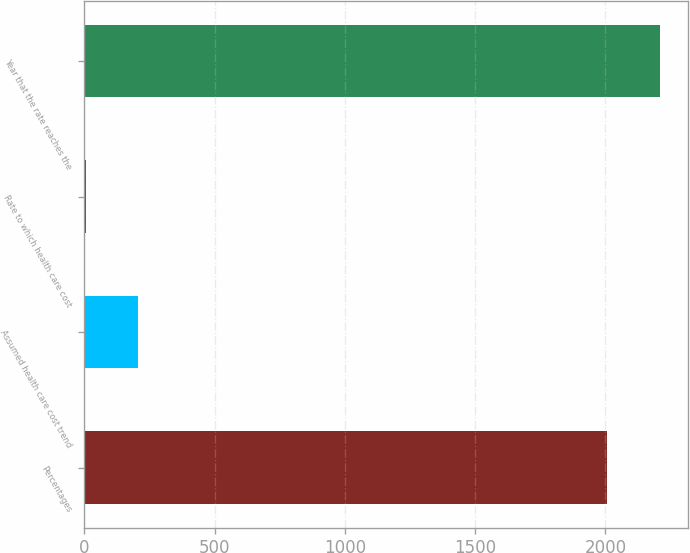Convert chart. <chart><loc_0><loc_0><loc_500><loc_500><bar_chart><fcel>Percentages<fcel>Assumed health care cost trend<fcel>Rate to which health care cost<fcel>Year that the rate reaches the<nl><fcel>2007<fcel>205.6<fcel>5<fcel>2207.6<nl></chart> 